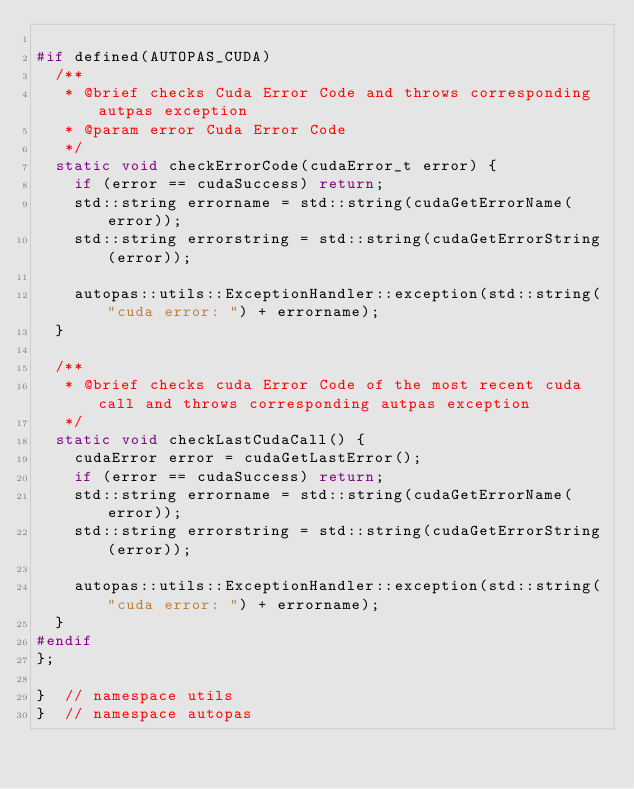Convert code to text. <code><loc_0><loc_0><loc_500><loc_500><_C_>
#if defined(AUTOPAS_CUDA)
  /**
   * @brief checks Cuda Error Code and throws corresponding autpas exception
   * @param error Cuda Error Code
   */
  static void checkErrorCode(cudaError_t error) {
    if (error == cudaSuccess) return;
    std::string errorname = std::string(cudaGetErrorName(error));
    std::string errorstring = std::string(cudaGetErrorString(error));

    autopas::utils::ExceptionHandler::exception(std::string("cuda error: ") + errorname);
  }

  /**
   * @brief checks cuda Error Code of the most recent cuda call and throws corresponding autpas exception
   */
  static void checkLastCudaCall() {
    cudaError error = cudaGetLastError();
    if (error == cudaSuccess) return;
    std::string errorname = std::string(cudaGetErrorName(error));
    std::string errorstring = std::string(cudaGetErrorString(error));

    autopas::utils::ExceptionHandler::exception(std::string("cuda error: ") + errorname);
  }
#endif
};

}  // namespace utils
}  // namespace autopas
</code> 